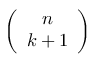<formula> <loc_0><loc_0><loc_500><loc_500>\left ( \begin{array} { c } { n } \\ { k + 1 } \end{array} \right )</formula> 